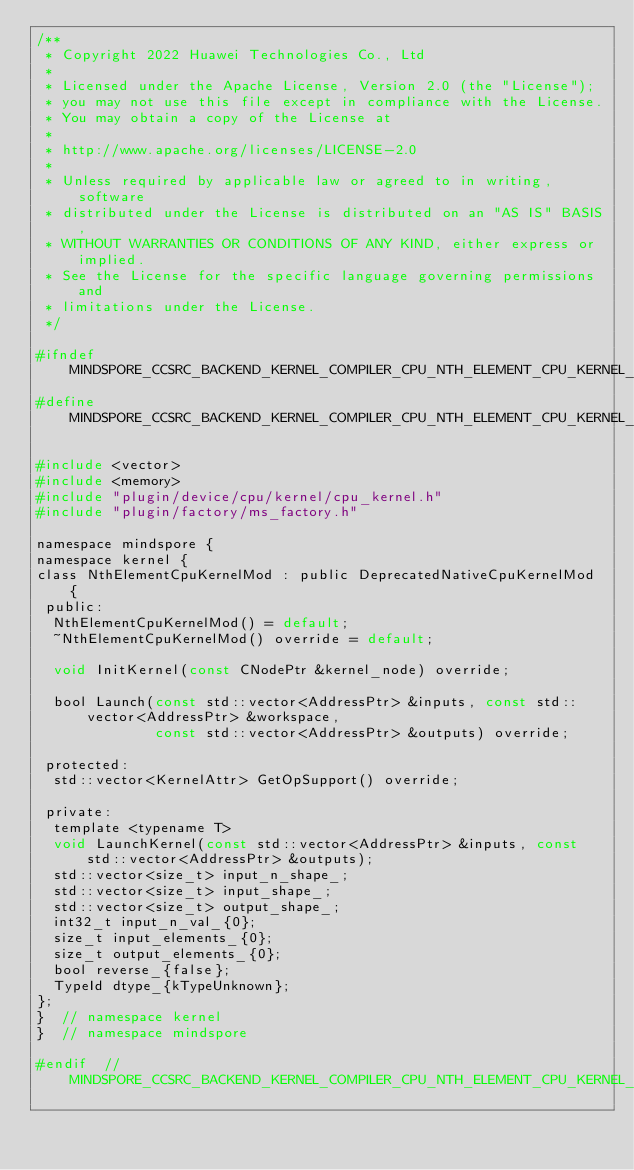Convert code to text. <code><loc_0><loc_0><loc_500><loc_500><_C_>/**
 * Copyright 2022 Huawei Technologies Co., Ltd
 *
 * Licensed under the Apache License, Version 2.0 (the "License");
 * you may not use this file except in compliance with the License.
 * You may obtain a copy of the License at
 *
 * http://www.apache.org/licenses/LICENSE-2.0
 *
 * Unless required by applicable law or agreed to in writing, software
 * distributed under the License is distributed on an "AS IS" BASIS,
 * WITHOUT WARRANTIES OR CONDITIONS OF ANY KIND, either express or implied.
 * See the License for the specific language governing permissions and
 * limitations under the License.
 */

#ifndef MINDSPORE_CCSRC_BACKEND_KERNEL_COMPILER_CPU_NTH_ELEMENT_CPU_KERNEL_H_
#define MINDSPORE_CCSRC_BACKEND_KERNEL_COMPILER_CPU_NTH_ELEMENT_CPU_KERNEL_H_

#include <vector>
#include <memory>
#include "plugin/device/cpu/kernel/cpu_kernel.h"
#include "plugin/factory/ms_factory.h"

namespace mindspore {
namespace kernel {
class NthElementCpuKernelMod : public DeprecatedNativeCpuKernelMod {
 public:
  NthElementCpuKernelMod() = default;
  ~NthElementCpuKernelMod() override = default;

  void InitKernel(const CNodePtr &kernel_node) override;

  bool Launch(const std::vector<AddressPtr> &inputs, const std::vector<AddressPtr> &workspace,
              const std::vector<AddressPtr> &outputs) override;

 protected:
  std::vector<KernelAttr> GetOpSupport() override;

 private:
  template <typename T>
  void LaunchKernel(const std::vector<AddressPtr> &inputs, const std::vector<AddressPtr> &outputs);
  std::vector<size_t> input_n_shape_;
  std::vector<size_t> input_shape_;
  std::vector<size_t> output_shape_;
  int32_t input_n_val_{0};
  size_t input_elements_{0};
  size_t output_elements_{0};
  bool reverse_{false};
  TypeId dtype_{kTypeUnknown};
};
}  // namespace kernel
}  // namespace mindspore

#endif  // MINDSPORE_CCSRC_BACKEND_KERNEL_COMPILER_CPU_NTH_ELEMENT_CPU_KERNEL_H_
</code> 